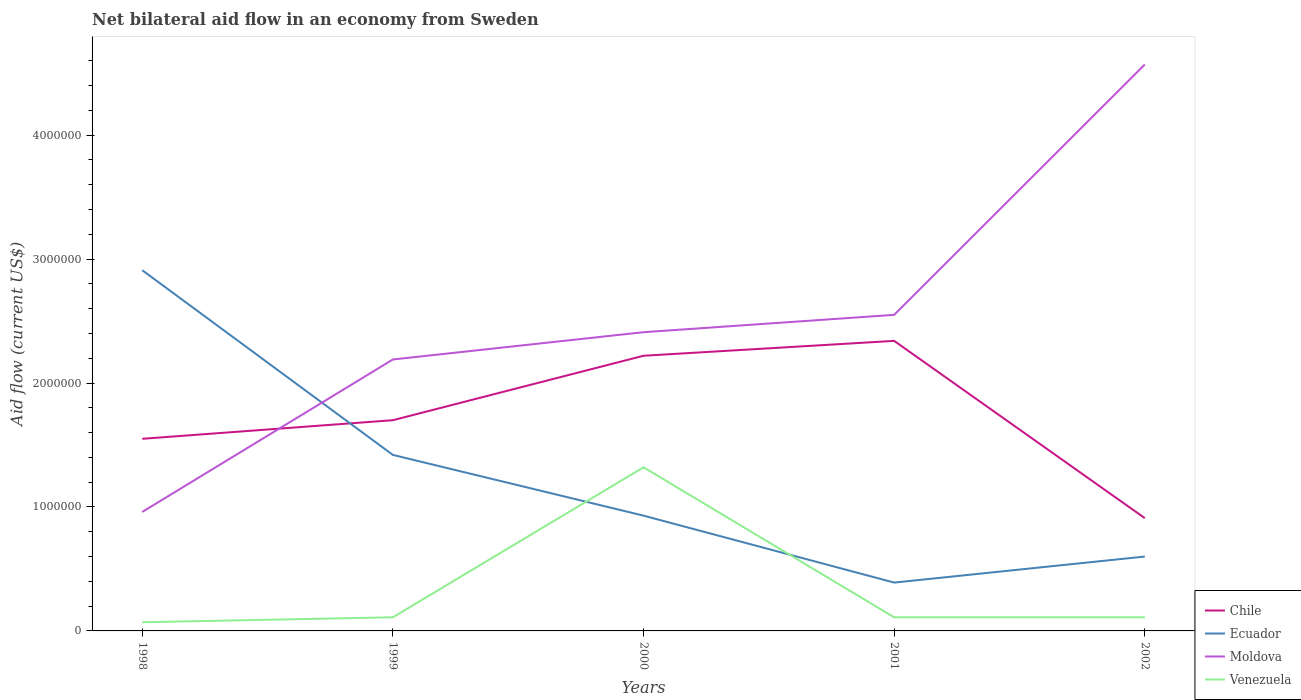How many different coloured lines are there?
Ensure brevity in your answer.  4. Across all years, what is the maximum net bilateral aid flow in Moldova?
Provide a short and direct response. 9.60e+05. What is the total net bilateral aid flow in Moldova in the graph?
Your answer should be very brief. -1.23e+06. What is the difference between the highest and the second highest net bilateral aid flow in Chile?
Keep it short and to the point. 1.43e+06. What is the difference between the highest and the lowest net bilateral aid flow in Chile?
Provide a succinct answer. 2. What is the difference between two consecutive major ticks on the Y-axis?
Your answer should be compact. 1.00e+06. Where does the legend appear in the graph?
Ensure brevity in your answer.  Bottom right. How many legend labels are there?
Offer a very short reply. 4. How are the legend labels stacked?
Give a very brief answer. Vertical. What is the title of the graph?
Ensure brevity in your answer.  Net bilateral aid flow in an economy from Sweden. What is the label or title of the X-axis?
Your response must be concise. Years. What is the label or title of the Y-axis?
Offer a terse response. Aid flow (current US$). What is the Aid flow (current US$) in Chile in 1998?
Offer a very short reply. 1.55e+06. What is the Aid flow (current US$) of Ecuador in 1998?
Ensure brevity in your answer.  2.91e+06. What is the Aid flow (current US$) of Moldova in 1998?
Give a very brief answer. 9.60e+05. What is the Aid flow (current US$) in Venezuela in 1998?
Offer a terse response. 7.00e+04. What is the Aid flow (current US$) of Chile in 1999?
Give a very brief answer. 1.70e+06. What is the Aid flow (current US$) of Ecuador in 1999?
Offer a very short reply. 1.42e+06. What is the Aid flow (current US$) of Moldova in 1999?
Your answer should be compact. 2.19e+06. What is the Aid flow (current US$) of Venezuela in 1999?
Your response must be concise. 1.10e+05. What is the Aid flow (current US$) of Chile in 2000?
Provide a succinct answer. 2.22e+06. What is the Aid flow (current US$) in Ecuador in 2000?
Offer a terse response. 9.30e+05. What is the Aid flow (current US$) of Moldova in 2000?
Give a very brief answer. 2.41e+06. What is the Aid flow (current US$) of Venezuela in 2000?
Provide a short and direct response. 1.32e+06. What is the Aid flow (current US$) of Chile in 2001?
Give a very brief answer. 2.34e+06. What is the Aid flow (current US$) in Moldova in 2001?
Your response must be concise. 2.55e+06. What is the Aid flow (current US$) of Chile in 2002?
Ensure brevity in your answer.  9.10e+05. What is the Aid flow (current US$) in Ecuador in 2002?
Keep it short and to the point. 6.00e+05. What is the Aid flow (current US$) of Moldova in 2002?
Make the answer very short. 4.57e+06. Across all years, what is the maximum Aid flow (current US$) of Chile?
Your answer should be compact. 2.34e+06. Across all years, what is the maximum Aid flow (current US$) in Ecuador?
Your answer should be very brief. 2.91e+06. Across all years, what is the maximum Aid flow (current US$) in Moldova?
Your response must be concise. 4.57e+06. Across all years, what is the maximum Aid flow (current US$) in Venezuela?
Ensure brevity in your answer.  1.32e+06. Across all years, what is the minimum Aid flow (current US$) of Chile?
Provide a short and direct response. 9.10e+05. Across all years, what is the minimum Aid flow (current US$) in Ecuador?
Your answer should be very brief. 3.90e+05. Across all years, what is the minimum Aid flow (current US$) in Moldova?
Give a very brief answer. 9.60e+05. Across all years, what is the minimum Aid flow (current US$) in Venezuela?
Provide a short and direct response. 7.00e+04. What is the total Aid flow (current US$) of Chile in the graph?
Your response must be concise. 8.72e+06. What is the total Aid flow (current US$) in Ecuador in the graph?
Make the answer very short. 6.25e+06. What is the total Aid flow (current US$) in Moldova in the graph?
Keep it short and to the point. 1.27e+07. What is the total Aid flow (current US$) in Venezuela in the graph?
Keep it short and to the point. 1.72e+06. What is the difference between the Aid flow (current US$) of Chile in 1998 and that in 1999?
Give a very brief answer. -1.50e+05. What is the difference between the Aid flow (current US$) of Ecuador in 1998 and that in 1999?
Your answer should be compact. 1.49e+06. What is the difference between the Aid flow (current US$) of Moldova in 1998 and that in 1999?
Offer a terse response. -1.23e+06. What is the difference between the Aid flow (current US$) in Chile in 1998 and that in 2000?
Provide a short and direct response. -6.70e+05. What is the difference between the Aid flow (current US$) of Ecuador in 1998 and that in 2000?
Make the answer very short. 1.98e+06. What is the difference between the Aid flow (current US$) in Moldova in 1998 and that in 2000?
Provide a short and direct response. -1.45e+06. What is the difference between the Aid flow (current US$) in Venezuela in 1998 and that in 2000?
Your answer should be compact. -1.25e+06. What is the difference between the Aid flow (current US$) in Chile in 1998 and that in 2001?
Your answer should be very brief. -7.90e+05. What is the difference between the Aid flow (current US$) of Ecuador in 1998 and that in 2001?
Your answer should be very brief. 2.52e+06. What is the difference between the Aid flow (current US$) of Moldova in 1998 and that in 2001?
Offer a very short reply. -1.59e+06. What is the difference between the Aid flow (current US$) of Venezuela in 1998 and that in 2001?
Your response must be concise. -4.00e+04. What is the difference between the Aid flow (current US$) in Chile in 1998 and that in 2002?
Ensure brevity in your answer.  6.40e+05. What is the difference between the Aid flow (current US$) of Ecuador in 1998 and that in 2002?
Make the answer very short. 2.31e+06. What is the difference between the Aid flow (current US$) of Moldova in 1998 and that in 2002?
Provide a succinct answer. -3.61e+06. What is the difference between the Aid flow (current US$) of Chile in 1999 and that in 2000?
Your answer should be compact. -5.20e+05. What is the difference between the Aid flow (current US$) of Moldova in 1999 and that in 2000?
Make the answer very short. -2.20e+05. What is the difference between the Aid flow (current US$) in Venezuela in 1999 and that in 2000?
Give a very brief answer. -1.21e+06. What is the difference between the Aid flow (current US$) of Chile in 1999 and that in 2001?
Your response must be concise. -6.40e+05. What is the difference between the Aid flow (current US$) in Ecuador in 1999 and that in 2001?
Your answer should be compact. 1.03e+06. What is the difference between the Aid flow (current US$) of Moldova in 1999 and that in 2001?
Offer a very short reply. -3.60e+05. What is the difference between the Aid flow (current US$) of Venezuela in 1999 and that in 2001?
Make the answer very short. 0. What is the difference between the Aid flow (current US$) of Chile in 1999 and that in 2002?
Ensure brevity in your answer.  7.90e+05. What is the difference between the Aid flow (current US$) of Ecuador in 1999 and that in 2002?
Your answer should be compact. 8.20e+05. What is the difference between the Aid flow (current US$) of Moldova in 1999 and that in 2002?
Ensure brevity in your answer.  -2.38e+06. What is the difference between the Aid flow (current US$) of Chile in 2000 and that in 2001?
Your answer should be very brief. -1.20e+05. What is the difference between the Aid flow (current US$) in Ecuador in 2000 and that in 2001?
Your response must be concise. 5.40e+05. What is the difference between the Aid flow (current US$) in Moldova in 2000 and that in 2001?
Provide a succinct answer. -1.40e+05. What is the difference between the Aid flow (current US$) in Venezuela in 2000 and that in 2001?
Make the answer very short. 1.21e+06. What is the difference between the Aid flow (current US$) in Chile in 2000 and that in 2002?
Your response must be concise. 1.31e+06. What is the difference between the Aid flow (current US$) in Moldova in 2000 and that in 2002?
Provide a short and direct response. -2.16e+06. What is the difference between the Aid flow (current US$) of Venezuela in 2000 and that in 2002?
Make the answer very short. 1.21e+06. What is the difference between the Aid flow (current US$) in Chile in 2001 and that in 2002?
Give a very brief answer. 1.43e+06. What is the difference between the Aid flow (current US$) of Ecuador in 2001 and that in 2002?
Your answer should be compact. -2.10e+05. What is the difference between the Aid flow (current US$) of Moldova in 2001 and that in 2002?
Give a very brief answer. -2.02e+06. What is the difference between the Aid flow (current US$) in Venezuela in 2001 and that in 2002?
Offer a terse response. 0. What is the difference between the Aid flow (current US$) of Chile in 1998 and the Aid flow (current US$) of Moldova in 1999?
Offer a very short reply. -6.40e+05. What is the difference between the Aid flow (current US$) in Chile in 1998 and the Aid flow (current US$) in Venezuela in 1999?
Your response must be concise. 1.44e+06. What is the difference between the Aid flow (current US$) of Ecuador in 1998 and the Aid flow (current US$) of Moldova in 1999?
Offer a very short reply. 7.20e+05. What is the difference between the Aid flow (current US$) in Ecuador in 1998 and the Aid flow (current US$) in Venezuela in 1999?
Your response must be concise. 2.80e+06. What is the difference between the Aid flow (current US$) of Moldova in 1998 and the Aid flow (current US$) of Venezuela in 1999?
Keep it short and to the point. 8.50e+05. What is the difference between the Aid flow (current US$) of Chile in 1998 and the Aid flow (current US$) of Ecuador in 2000?
Ensure brevity in your answer.  6.20e+05. What is the difference between the Aid flow (current US$) of Chile in 1998 and the Aid flow (current US$) of Moldova in 2000?
Keep it short and to the point. -8.60e+05. What is the difference between the Aid flow (current US$) in Chile in 1998 and the Aid flow (current US$) in Venezuela in 2000?
Provide a short and direct response. 2.30e+05. What is the difference between the Aid flow (current US$) of Ecuador in 1998 and the Aid flow (current US$) of Venezuela in 2000?
Your answer should be compact. 1.59e+06. What is the difference between the Aid flow (current US$) in Moldova in 1998 and the Aid flow (current US$) in Venezuela in 2000?
Provide a succinct answer. -3.60e+05. What is the difference between the Aid flow (current US$) in Chile in 1998 and the Aid flow (current US$) in Ecuador in 2001?
Give a very brief answer. 1.16e+06. What is the difference between the Aid flow (current US$) of Chile in 1998 and the Aid flow (current US$) of Moldova in 2001?
Provide a succinct answer. -1.00e+06. What is the difference between the Aid flow (current US$) in Chile in 1998 and the Aid flow (current US$) in Venezuela in 2001?
Your response must be concise. 1.44e+06. What is the difference between the Aid flow (current US$) in Ecuador in 1998 and the Aid flow (current US$) in Moldova in 2001?
Offer a terse response. 3.60e+05. What is the difference between the Aid flow (current US$) in Ecuador in 1998 and the Aid flow (current US$) in Venezuela in 2001?
Give a very brief answer. 2.80e+06. What is the difference between the Aid flow (current US$) in Moldova in 1998 and the Aid flow (current US$) in Venezuela in 2001?
Keep it short and to the point. 8.50e+05. What is the difference between the Aid flow (current US$) in Chile in 1998 and the Aid flow (current US$) in Ecuador in 2002?
Offer a very short reply. 9.50e+05. What is the difference between the Aid flow (current US$) of Chile in 1998 and the Aid flow (current US$) of Moldova in 2002?
Offer a terse response. -3.02e+06. What is the difference between the Aid flow (current US$) of Chile in 1998 and the Aid flow (current US$) of Venezuela in 2002?
Your answer should be very brief. 1.44e+06. What is the difference between the Aid flow (current US$) in Ecuador in 1998 and the Aid flow (current US$) in Moldova in 2002?
Provide a succinct answer. -1.66e+06. What is the difference between the Aid flow (current US$) in Ecuador in 1998 and the Aid flow (current US$) in Venezuela in 2002?
Make the answer very short. 2.80e+06. What is the difference between the Aid flow (current US$) of Moldova in 1998 and the Aid flow (current US$) of Venezuela in 2002?
Your answer should be compact. 8.50e+05. What is the difference between the Aid flow (current US$) of Chile in 1999 and the Aid flow (current US$) of Ecuador in 2000?
Your answer should be compact. 7.70e+05. What is the difference between the Aid flow (current US$) of Chile in 1999 and the Aid flow (current US$) of Moldova in 2000?
Your response must be concise. -7.10e+05. What is the difference between the Aid flow (current US$) of Ecuador in 1999 and the Aid flow (current US$) of Moldova in 2000?
Your answer should be very brief. -9.90e+05. What is the difference between the Aid flow (current US$) of Ecuador in 1999 and the Aid flow (current US$) of Venezuela in 2000?
Provide a short and direct response. 1.00e+05. What is the difference between the Aid flow (current US$) in Moldova in 1999 and the Aid flow (current US$) in Venezuela in 2000?
Offer a terse response. 8.70e+05. What is the difference between the Aid flow (current US$) in Chile in 1999 and the Aid flow (current US$) in Ecuador in 2001?
Provide a succinct answer. 1.31e+06. What is the difference between the Aid flow (current US$) of Chile in 1999 and the Aid flow (current US$) of Moldova in 2001?
Make the answer very short. -8.50e+05. What is the difference between the Aid flow (current US$) of Chile in 1999 and the Aid flow (current US$) of Venezuela in 2001?
Offer a very short reply. 1.59e+06. What is the difference between the Aid flow (current US$) of Ecuador in 1999 and the Aid flow (current US$) of Moldova in 2001?
Ensure brevity in your answer.  -1.13e+06. What is the difference between the Aid flow (current US$) in Ecuador in 1999 and the Aid flow (current US$) in Venezuela in 2001?
Keep it short and to the point. 1.31e+06. What is the difference between the Aid flow (current US$) in Moldova in 1999 and the Aid flow (current US$) in Venezuela in 2001?
Offer a terse response. 2.08e+06. What is the difference between the Aid flow (current US$) in Chile in 1999 and the Aid flow (current US$) in Ecuador in 2002?
Your answer should be compact. 1.10e+06. What is the difference between the Aid flow (current US$) in Chile in 1999 and the Aid flow (current US$) in Moldova in 2002?
Provide a short and direct response. -2.87e+06. What is the difference between the Aid flow (current US$) in Chile in 1999 and the Aid flow (current US$) in Venezuela in 2002?
Make the answer very short. 1.59e+06. What is the difference between the Aid flow (current US$) in Ecuador in 1999 and the Aid flow (current US$) in Moldova in 2002?
Give a very brief answer. -3.15e+06. What is the difference between the Aid flow (current US$) of Ecuador in 1999 and the Aid flow (current US$) of Venezuela in 2002?
Your answer should be very brief. 1.31e+06. What is the difference between the Aid flow (current US$) in Moldova in 1999 and the Aid flow (current US$) in Venezuela in 2002?
Give a very brief answer. 2.08e+06. What is the difference between the Aid flow (current US$) in Chile in 2000 and the Aid flow (current US$) in Ecuador in 2001?
Keep it short and to the point. 1.83e+06. What is the difference between the Aid flow (current US$) of Chile in 2000 and the Aid flow (current US$) of Moldova in 2001?
Provide a short and direct response. -3.30e+05. What is the difference between the Aid flow (current US$) of Chile in 2000 and the Aid flow (current US$) of Venezuela in 2001?
Offer a terse response. 2.11e+06. What is the difference between the Aid flow (current US$) in Ecuador in 2000 and the Aid flow (current US$) in Moldova in 2001?
Your answer should be compact. -1.62e+06. What is the difference between the Aid flow (current US$) in Ecuador in 2000 and the Aid flow (current US$) in Venezuela in 2001?
Give a very brief answer. 8.20e+05. What is the difference between the Aid flow (current US$) in Moldova in 2000 and the Aid flow (current US$) in Venezuela in 2001?
Ensure brevity in your answer.  2.30e+06. What is the difference between the Aid flow (current US$) in Chile in 2000 and the Aid flow (current US$) in Ecuador in 2002?
Provide a succinct answer. 1.62e+06. What is the difference between the Aid flow (current US$) of Chile in 2000 and the Aid flow (current US$) of Moldova in 2002?
Make the answer very short. -2.35e+06. What is the difference between the Aid flow (current US$) in Chile in 2000 and the Aid flow (current US$) in Venezuela in 2002?
Your response must be concise. 2.11e+06. What is the difference between the Aid flow (current US$) in Ecuador in 2000 and the Aid flow (current US$) in Moldova in 2002?
Your answer should be compact. -3.64e+06. What is the difference between the Aid flow (current US$) of Ecuador in 2000 and the Aid flow (current US$) of Venezuela in 2002?
Ensure brevity in your answer.  8.20e+05. What is the difference between the Aid flow (current US$) in Moldova in 2000 and the Aid flow (current US$) in Venezuela in 2002?
Your response must be concise. 2.30e+06. What is the difference between the Aid flow (current US$) in Chile in 2001 and the Aid flow (current US$) in Ecuador in 2002?
Keep it short and to the point. 1.74e+06. What is the difference between the Aid flow (current US$) of Chile in 2001 and the Aid flow (current US$) of Moldova in 2002?
Your response must be concise. -2.23e+06. What is the difference between the Aid flow (current US$) of Chile in 2001 and the Aid flow (current US$) of Venezuela in 2002?
Keep it short and to the point. 2.23e+06. What is the difference between the Aid flow (current US$) of Ecuador in 2001 and the Aid flow (current US$) of Moldova in 2002?
Your answer should be compact. -4.18e+06. What is the difference between the Aid flow (current US$) in Ecuador in 2001 and the Aid flow (current US$) in Venezuela in 2002?
Offer a very short reply. 2.80e+05. What is the difference between the Aid flow (current US$) in Moldova in 2001 and the Aid flow (current US$) in Venezuela in 2002?
Make the answer very short. 2.44e+06. What is the average Aid flow (current US$) of Chile per year?
Offer a terse response. 1.74e+06. What is the average Aid flow (current US$) of Ecuador per year?
Offer a very short reply. 1.25e+06. What is the average Aid flow (current US$) of Moldova per year?
Your answer should be compact. 2.54e+06. What is the average Aid flow (current US$) in Venezuela per year?
Offer a terse response. 3.44e+05. In the year 1998, what is the difference between the Aid flow (current US$) of Chile and Aid flow (current US$) of Ecuador?
Provide a short and direct response. -1.36e+06. In the year 1998, what is the difference between the Aid flow (current US$) of Chile and Aid flow (current US$) of Moldova?
Keep it short and to the point. 5.90e+05. In the year 1998, what is the difference between the Aid flow (current US$) in Chile and Aid flow (current US$) in Venezuela?
Make the answer very short. 1.48e+06. In the year 1998, what is the difference between the Aid flow (current US$) in Ecuador and Aid flow (current US$) in Moldova?
Give a very brief answer. 1.95e+06. In the year 1998, what is the difference between the Aid flow (current US$) of Ecuador and Aid flow (current US$) of Venezuela?
Offer a very short reply. 2.84e+06. In the year 1998, what is the difference between the Aid flow (current US$) of Moldova and Aid flow (current US$) of Venezuela?
Provide a short and direct response. 8.90e+05. In the year 1999, what is the difference between the Aid flow (current US$) in Chile and Aid flow (current US$) in Ecuador?
Keep it short and to the point. 2.80e+05. In the year 1999, what is the difference between the Aid flow (current US$) in Chile and Aid flow (current US$) in Moldova?
Ensure brevity in your answer.  -4.90e+05. In the year 1999, what is the difference between the Aid flow (current US$) in Chile and Aid flow (current US$) in Venezuela?
Provide a short and direct response. 1.59e+06. In the year 1999, what is the difference between the Aid flow (current US$) in Ecuador and Aid flow (current US$) in Moldova?
Provide a succinct answer. -7.70e+05. In the year 1999, what is the difference between the Aid flow (current US$) in Ecuador and Aid flow (current US$) in Venezuela?
Your answer should be very brief. 1.31e+06. In the year 1999, what is the difference between the Aid flow (current US$) of Moldova and Aid flow (current US$) of Venezuela?
Offer a very short reply. 2.08e+06. In the year 2000, what is the difference between the Aid flow (current US$) of Chile and Aid flow (current US$) of Ecuador?
Provide a short and direct response. 1.29e+06. In the year 2000, what is the difference between the Aid flow (current US$) in Ecuador and Aid flow (current US$) in Moldova?
Ensure brevity in your answer.  -1.48e+06. In the year 2000, what is the difference between the Aid flow (current US$) in Ecuador and Aid flow (current US$) in Venezuela?
Your response must be concise. -3.90e+05. In the year 2000, what is the difference between the Aid flow (current US$) of Moldova and Aid flow (current US$) of Venezuela?
Offer a very short reply. 1.09e+06. In the year 2001, what is the difference between the Aid flow (current US$) of Chile and Aid flow (current US$) of Ecuador?
Your response must be concise. 1.95e+06. In the year 2001, what is the difference between the Aid flow (current US$) in Chile and Aid flow (current US$) in Moldova?
Offer a terse response. -2.10e+05. In the year 2001, what is the difference between the Aid flow (current US$) of Chile and Aid flow (current US$) of Venezuela?
Your answer should be very brief. 2.23e+06. In the year 2001, what is the difference between the Aid flow (current US$) of Ecuador and Aid flow (current US$) of Moldova?
Your answer should be compact. -2.16e+06. In the year 2001, what is the difference between the Aid flow (current US$) in Ecuador and Aid flow (current US$) in Venezuela?
Ensure brevity in your answer.  2.80e+05. In the year 2001, what is the difference between the Aid flow (current US$) of Moldova and Aid flow (current US$) of Venezuela?
Give a very brief answer. 2.44e+06. In the year 2002, what is the difference between the Aid flow (current US$) in Chile and Aid flow (current US$) in Ecuador?
Your answer should be very brief. 3.10e+05. In the year 2002, what is the difference between the Aid flow (current US$) of Chile and Aid flow (current US$) of Moldova?
Offer a very short reply. -3.66e+06. In the year 2002, what is the difference between the Aid flow (current US$) of Chile and Aid flow (current US$) of Venezuela?
Give a very brief answer. 8.00e+05. In the year 2002, what is the difference between the Aid flow (current US$) in Ecuador and Aid flow (current US$) in Moldova?
Provide a short and direct response. -3.97e+06. In the year 2002, what is the difference between the Aid flow (current US$) of Moldova and Aid flow (current US$) of Venezuela?
Provide a short and direct response. 4.46e+06. What is the ratio of the Aid flow (current US$) in Chile in 1998 to that in 1999?
Provide a succinct answer. 0.91. What is the ratio of the Aid flow (current US$) of Ecuador in 1998 to that in 1999?
Offer a terse response. 2.05. What is the ratio of the Aid flow (current US$) in Moldova in 1998 to that in 1999?
Offer a terse response. 0.44. What is the ratio of the Aid flow (current US$) of Venezuela in 1998 to that in 1999?
Make the answer very short. 0.64. What is the ratio of the Aid flow (current US$) in Chile in 1998 to that in 2000?
Make the answer very short. 0.7. What is the ratio of the Aid flow (current US$) of Ecuador in 1998 to that in 2000?
Keep it short and to the point. 3.13. What is the ratio of the Aid flow (current US$) of Moldova in 1998 to that in 2000?
Offer a terse response. 0.4. What is the ratio of the Aid flow (current US$) of Venezuela in 1998 to that in 2000?
Give a very brief answer. 0.05. What is the ratio of the Aid flow (current US$) in Chile in 1998 to that in 2001?
Offer a terse response. 0.66. What is the ratio of the Aid flow (current US$) in Ecuador in 1998 to that in 2001?
Your answer should be very brief. 7.46. What is the ratio of the Aid flow (current US$) of Moldova in 1998 to that in 2001?
Ensure brevity in your answer.  0.38. What is the ratio of the Aid flow (current US$) in Venezuela in 1998 to that in 2001?
Make the answer very short. 0.64. What is the ratio of the Aid flow (current US$) in Chile in 1998 to that in 2002?
Keep it short and to the point. 1.7. What is the ratio of the Aid flow (current US$) in Ecuador in 1998 to that in 2002?
Offer a very short reply. 4.85. What is the ratio of the Aid flow (current US$) in Moldova in 1998 to that in 2002?
Give a very brief answer. 0.21. What is the ratio of the Aid flow (current US$) in Venezuela in 1998 to that in 2002?
Offer a very short reply. 0.64. What is the ratio of the Aid flow (current US$) in Chile in 1999 to that in 2000?
Offer a terse response. 0.77. What is the ratio of the Aid flow (current US$) in Ecuador in 1999 to that in 2000?
Your response must be concise. 1.53. What is the ratio of the Aid flow (current US$) of Moldova in 1999 to that in 2000?
Provide a succinct answer. 0.91. What is the ratio of the Aid flow (current US$) of Venezuela in 1999 to that in 2000?
Ensure brevity in your answer.  0.08. What is the ratio of the Aid flow (current US$) in Chile in 1999 to that in 2001?
Offer a terse response. 0.73. What is the ratio of the Aid flow (current US$) in Ecuador in 1999 to that in 2001?
Provide a short and direct response. 3.64. What is the ratio of the Aid flow (current US$) of Moldova in 1999 to that in 2001?
Keep it short and to the point. 0.86. What is the ratio of the Aid flow (current US$) in Venezuela in 1999 to that in 2001?
Offer a very short reply. 1. What is the ratio of the Aid flow (current US$) in Chile in 1999 to that in 2002?
Ensure brevity in your answer.  1.87. What is the ratio of the Aid flow (current US$) in Ecuador in 1999 to that in 2002?
Provide a short and direct response. 2.37. What is the ratio of the Aid flow (current US$) in Moldova in 1999 to that in 2002?
Ensure brevity in your answer.  0.48. What is the ratio of the Aid flow (current US$) of Chile in 2000 to that in 2001?
Your answer should be very brief. 0.95. What is the ratio of the Aid flow (current US$) of Ecuador in 2000 to that in 2001?
Provide a short and direct response. 2.38. What is the ratio of the Aid flow (current US$) of Moldova in 2000 to that in 2001?
Your response must be concise. 0.95. What is the ratio of the Aid flow (current US$) of Chile in 2000 to that in 2002?
Ensure brevity in your answer.  2.44. What is the ratio of the Aid flow (current US$) of Ecuador in 2000 to that in 2002?
Give a very brief answer. 1.55. What is the ratio of the Aid flow (current US$) of Moldova in 2000 to that in 2002?
Give a very brief answer. 0.53. What is the ratio of the Aid flow (current US$) of Venezuela in 2000 to that in 2002?
Make the answer very short. 12. What is the ratio of the Aid flow (current US$) in Chile in 2001 to that in 2002?
Keep it short and to the point. 2.57. What is the ratio of the Aid flow (current US$) of Ecuador in 2001 to that in 2002?
Offer a very short reply. 0.65. What is the ratio of the Aid flow (current US$) of Moldova in 2001 to that in 2002?
Give a very brief answer. 0.56. What is the difference between the highest and the second highest Aid flow (current US$) of Chile?
Your answer should be very brief. 1.20e+05. What is the difference between the highest and the second highest Aid flow (current US$) in Ecuador?
Provide a succinct answer. 1.49e+06. What is the difference between the highest and the second highest Aid flow (current US$) in Moldova?
Your answer should be very brief. 2.02e+06. What is the difference between the highest and the second highest Aid flow (current US$) of Venezuela?
Provide a short and direct response. 1.21e+06. What is the difference between the highest and the lowest Aid flow (current US$) of Chile?
Your answer should be compact. 1.43e+06. What is the difference between the highest and the lowest Aid flow (current US$) of Ecuador?
Provide a succinct answer. 2.52e+06. What is the difference between the highest and the lowest Aid flow (current US$) of Moldova?
Provide a short and direct response. 3.61e+06. What is the difference between the highest and the lowest Aid flow (current US$) in Venezuela?
Provide a short and direct response. 1.25e+06. 